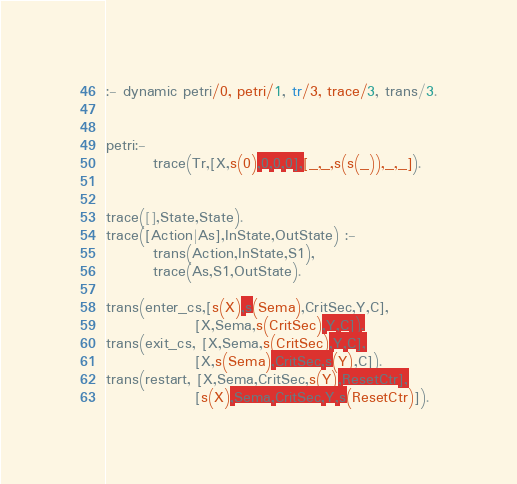<code> <loc_0><loc_0><loc_500><loc_500><_Perl_>:- dynamic petri/0, petri/1, tr/3, trace/3, trans/3.petri:-         trace(Tr,[X,s(0),0,0,0],[_,_,s(s(_)),_,_]).        trace([],State,State).trace([Action|As],InState,OutState) :-        trans(Action,InState,S1),        trace(As,S1,OutState).trans(enter_cs,[s(X),s(Sema),CritSec,Y,C],               [X,Sema,s(CritSec),Y,C]).trans(exit_cs, [X,Sema,s(CritSec),Y,C],               [X,s(Sema),CritSec,s(Y),C]).trans(restart, [X,Sema,CritSec,s(Y),ResetCtr],               [s(X),Sema,CritSec,Y,s(ResetCtr)]).</code> 